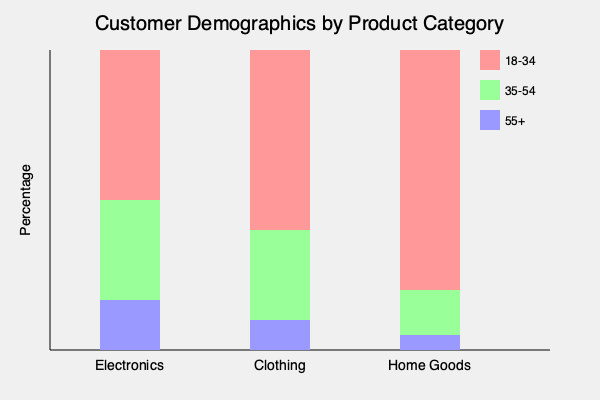Based on the stacked bar chart showing customer demographics across different product categories, which product category has the highest percentage of customers in the 35-54 age group, and what strategic marketing decision could be made based on this information? To answer this question, we need to analyze the stacked bar chart and follow these steps:

1. Identify the age group:
   - The 35-54 age group is represented by the green (#99ff99) section in each bar.

2. Compare the green sections across product categories:
   - Electronics: The green section is 50% of the bar (150 out of 300 pixels).
   - Clothing: The green section is 30% of the bar (90 out of 300 pixels).
   - Home Goods: The green section is 15% of the bar (45 out of 300 pixels).

3. Determine the highest percentage:
   - Electronics has the highest percentage at 50% for the 35-54 age group.

4. Consider strategic marketing decisions:
   - Given that Electronics has the highest percentage of customers in the 35-54 age group, a strategic marketing decision could be to focus on targeted marketing campaigns for this demographic within the Electronics category.
   - This could include:
     a) Developing promotions specifically tailored to the needs and preferences of 35-54 year-olds.
     b) Creating content marketing that resonates with this age group's lifestyle and tech usage.
     c) Emphasizing features of electronic products that are particularly appealing to this demographic.
     d) Utilizing marketing channels that are most effective in reaching this age group.

5. Conclusion:
   The Electronics category has the highest percentage of customers in the 35-54 age group, and a strategic marketing decision would be to create targeted campaigns for this demographic within the Electronics product line.
Answer: Electronics; create targeted campaigns for 35-54 demographic in Electronics. 